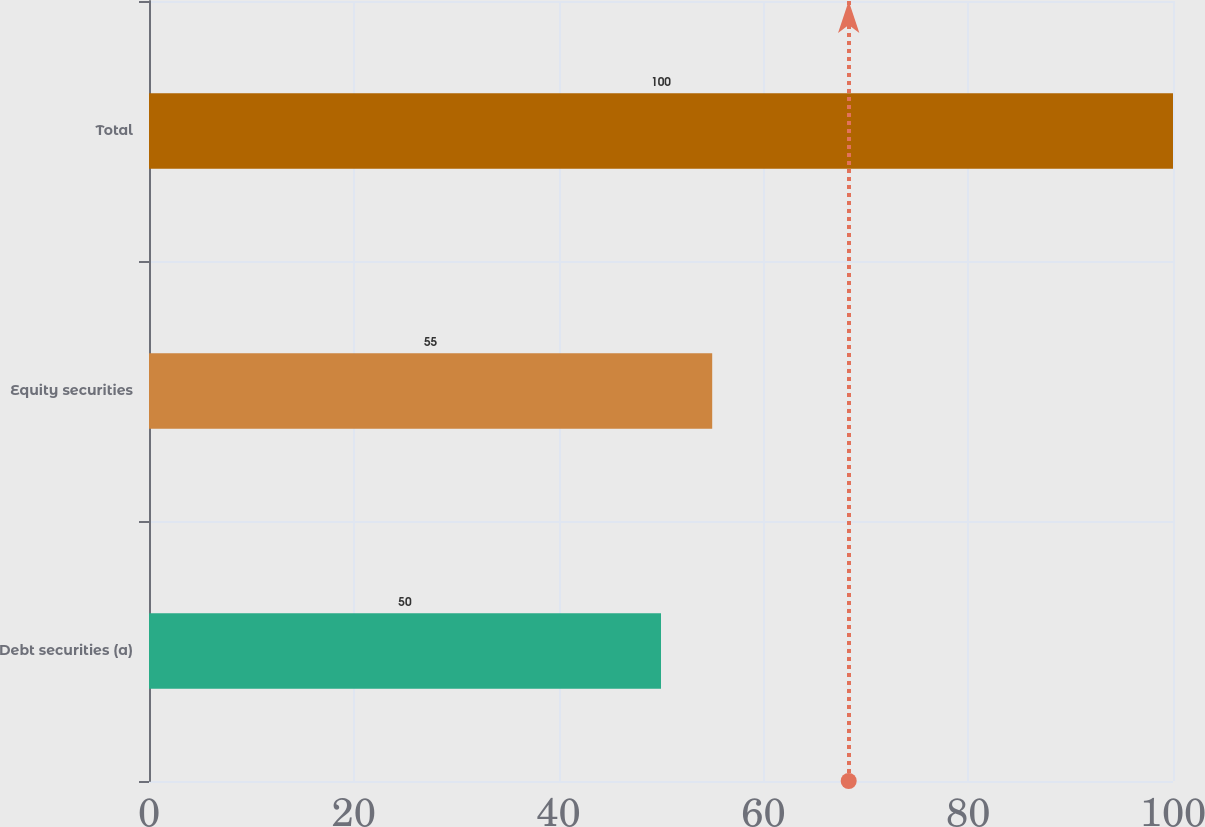Convert chart to OTSL. <chart><loc_0><loc_0><loc_500><loc_500><bar_chart><fcel>Debt securities (a)<fcel>Equity securities<fcel>Total<nl><fcel>50<fcel>55<fcel>100<nl></chart> 